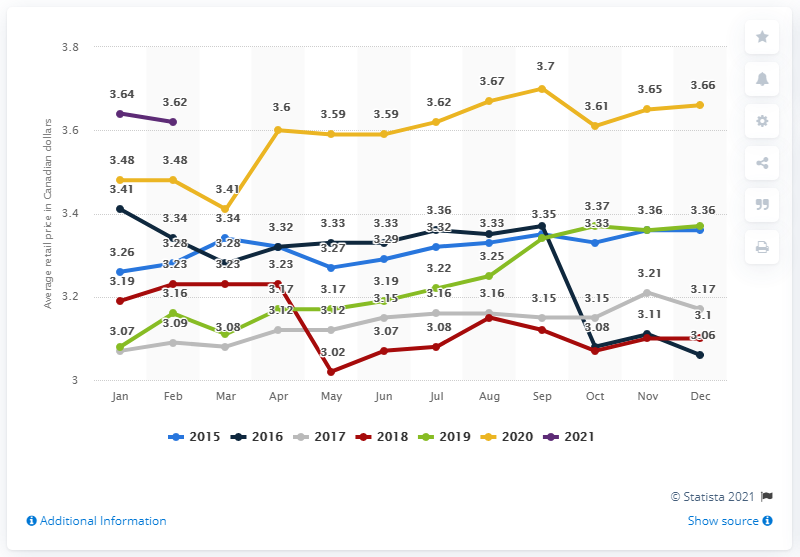Specify some key components in this picture. In February 2021, the average retail price for a dozen eggs in Canada was 3.62. 